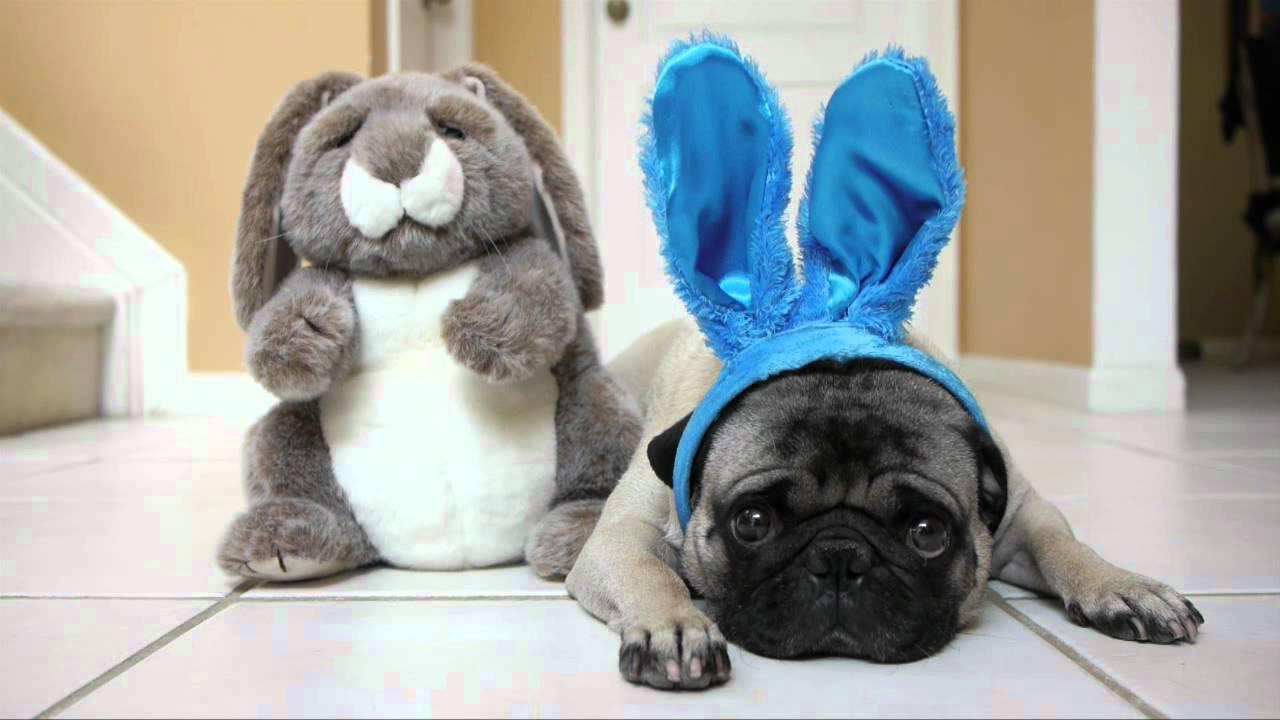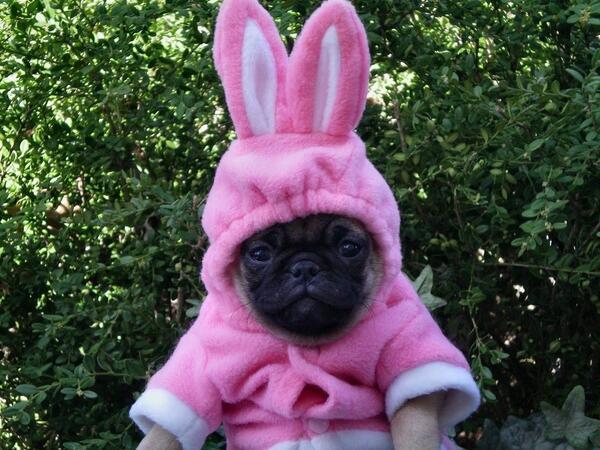The first image is the image on the left, the second image is the image on the right. Evaluate the accuracy of this statement regarding the images: "The left image shows a pug wearing bunny ears by a stuffed toy with bunny ears.". Is it true? Answer yes or no. Yes. The first image is the image on the left, the second image is the image on the right. Assess this claim about the two images: "there is a pug  wearing costume bunny ears laying next to a stuffed bunny toy". Correct or not? Answer yes or no. Yes. 